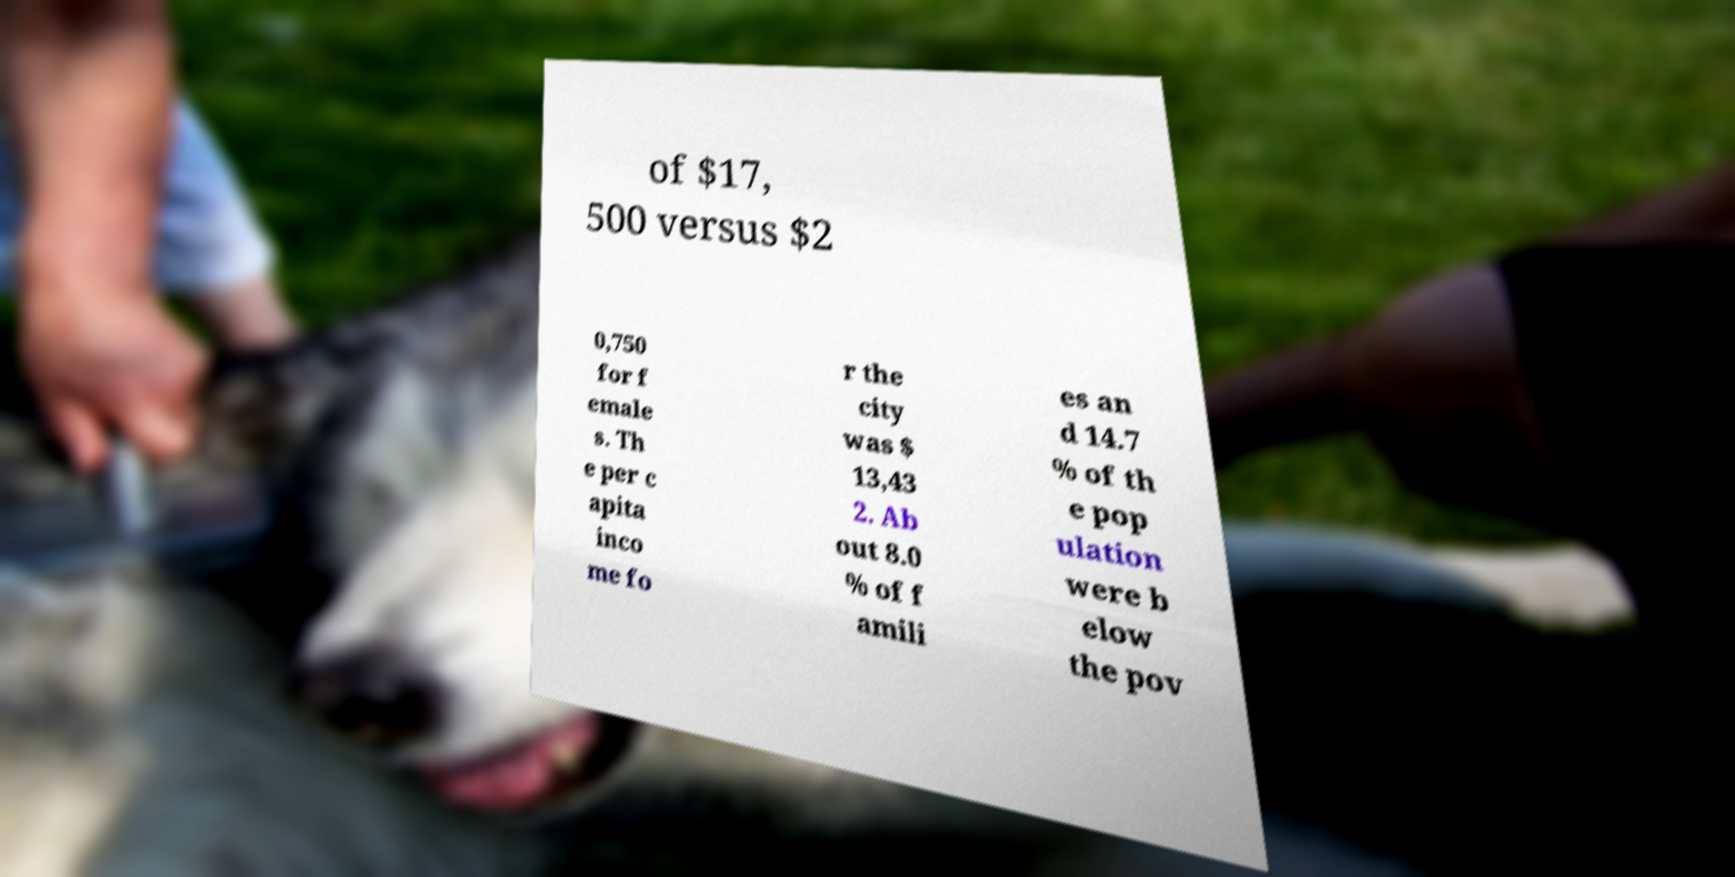Could you extract and type out the text from this image? of $17, 500 versus $2 0,750 for f emale s. Th e per c apita inco me fo r the city was $ 13,43 2. Ab out 8.0 % of f amili es an d 14.7 % of th e pop ulation were b elow the pov 